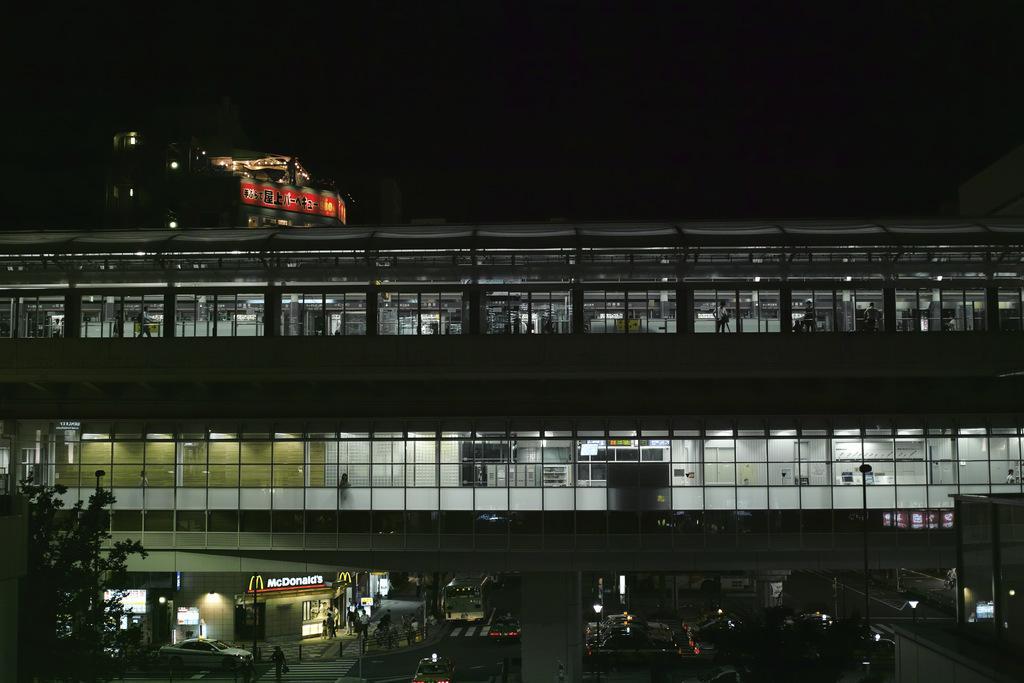How would you summarize this image in a sentence or two? In the foreground of this image, there is a building. On the left bottom, there is a tree and we can also see few vehicles, light poles, persons moving on the side path are on the bottom. On the top, there is the dark sky. 